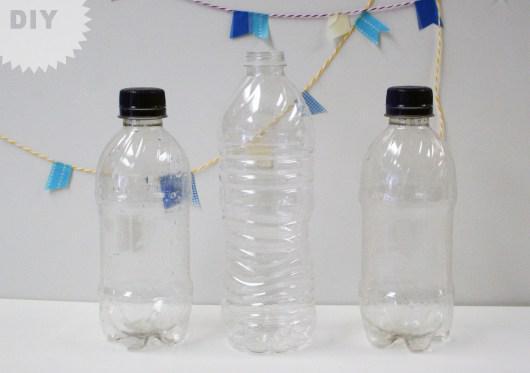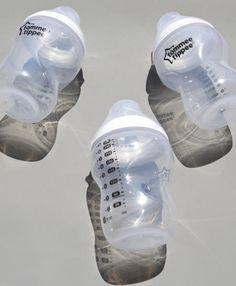The first image is the image on the left, the second image is the image on the right. For the images shown, is this caption "Three water bottles with blue caps are in a row." true? Answer yes or no. No. The first image is the image on the left, the second image is the image on the right. For the images displayed, is the sentence "The left image contains no more than one bottle." factually correct? Answer yes or no. No. 